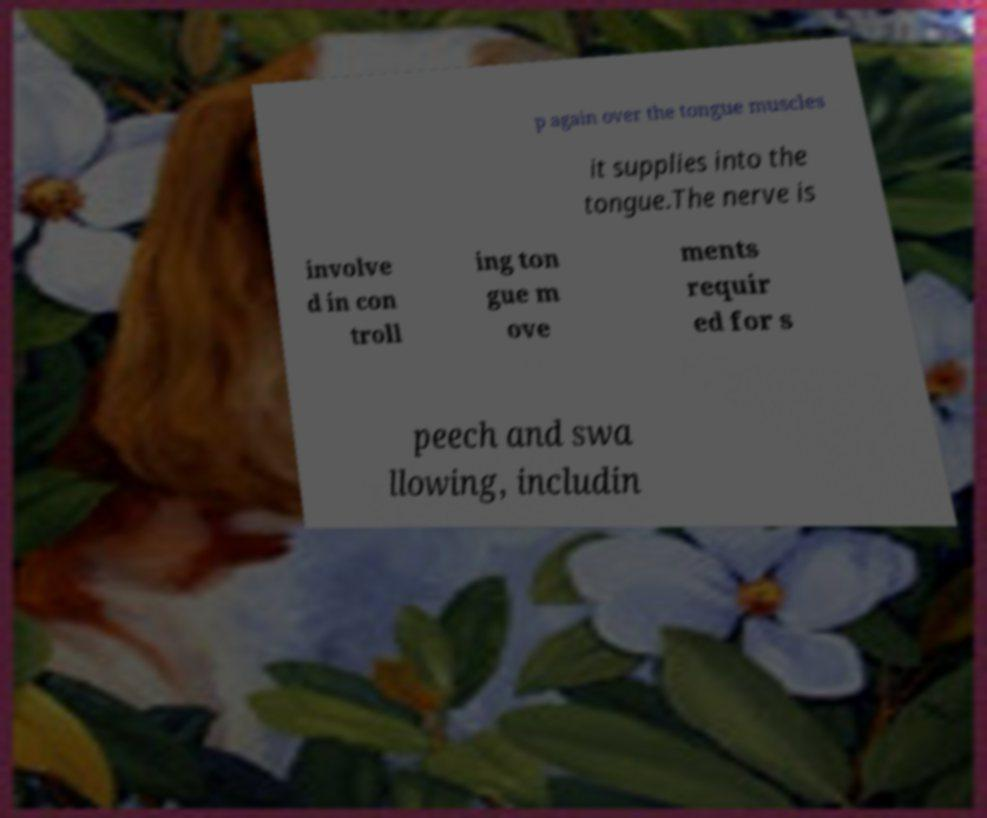I need the written content from this picture converted into text. Can you do that? p again over the tongue muscles it supplies into the tongue.The nerve is involve d in con troll ing ton gue m ove ments requir ed for s peech and swa llowing, includin 